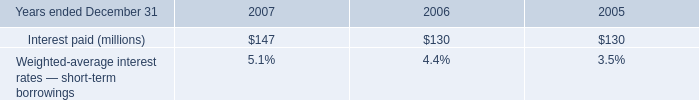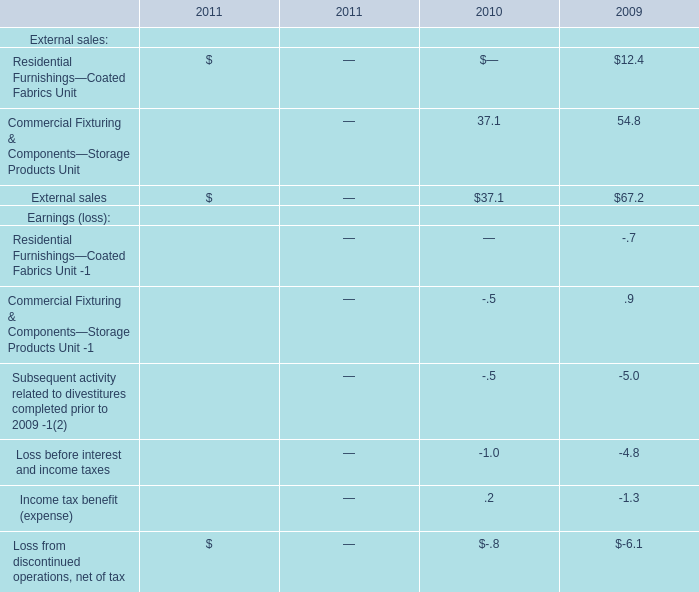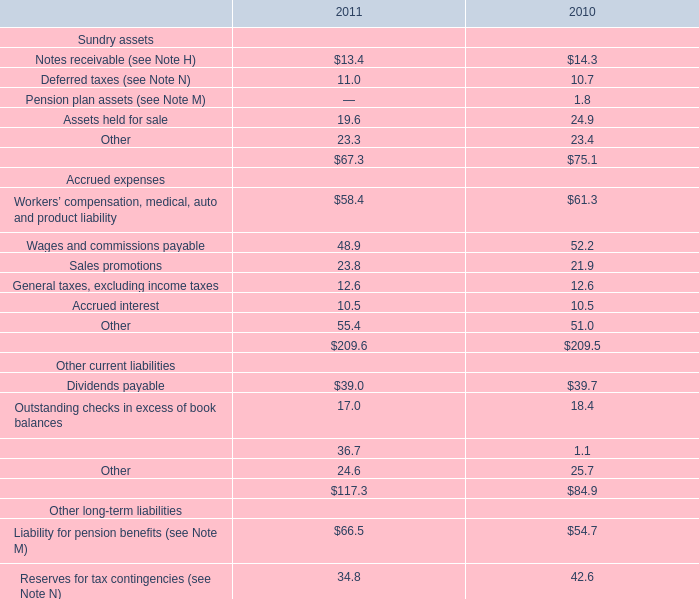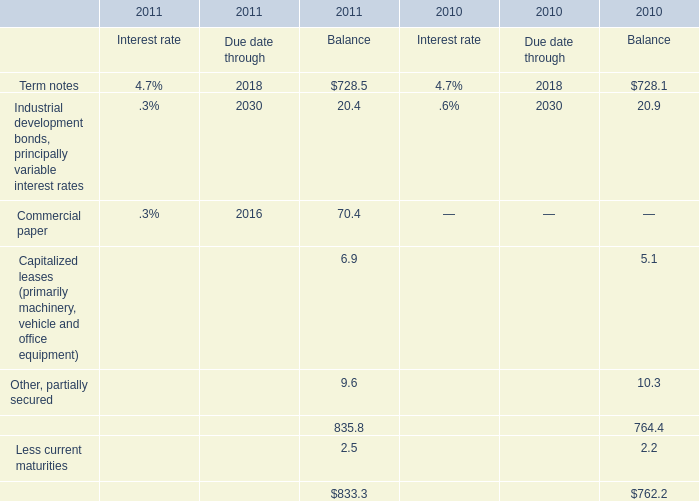What was the total amount of the Assets held for sale in the years where Deferred taxes (see Note N) greater than 0? 
Computations: (19.6 + 24.9)
Answer: 44.5. 